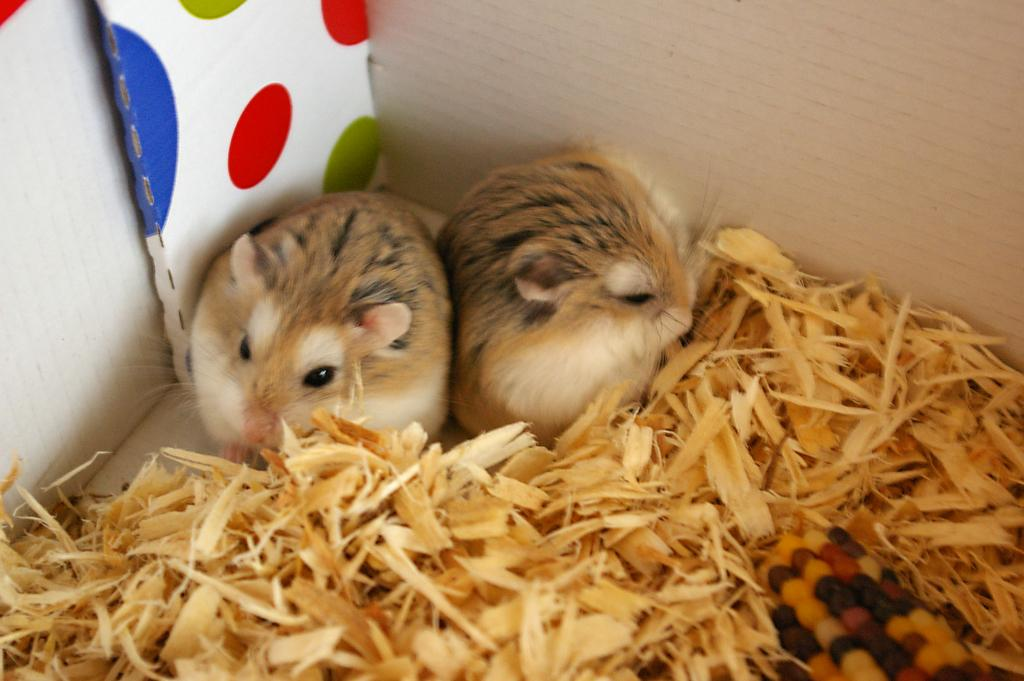How many hamsters are in the image? There are two hamsters in the image. What colors can be seen on the hamsters? The hamsters are brown, cream, and black in color. What type of material is visible in the image? There is wood dust visible in the image. What is in front of the hamsters? There is a colorful corn in front of the hamsters. What can be seen in the background of the image? There are walls visible in the background of the image. What is the price of the secretary's coat in the image? There is no secretary or coat present in the image. 